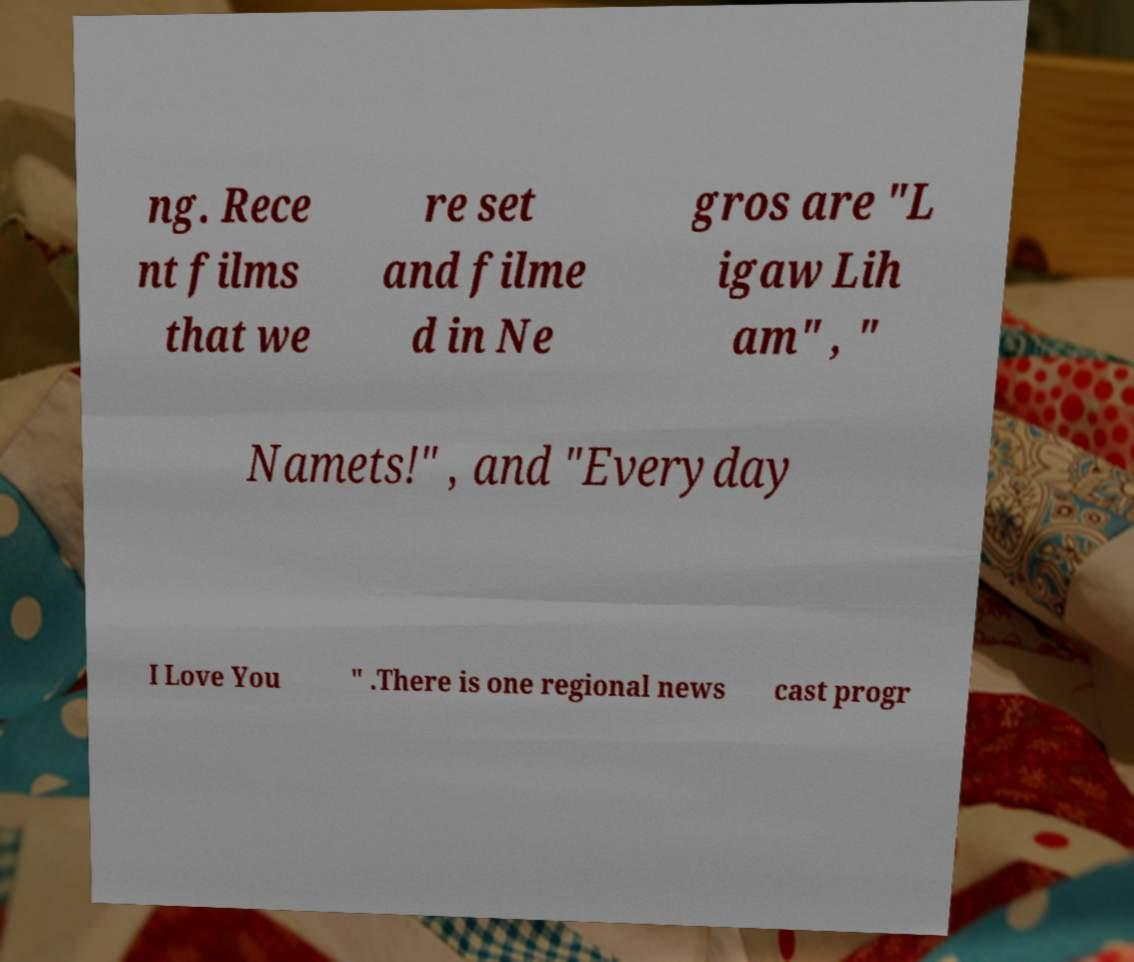I need the written content from this picture converted into text. Can you do that? ng. Rece nt films that we re set and filme d in Ne gros are "L igaw Lih am" , " Namets!" , and "Everyday I Love You " .There is one regional news cast progr 